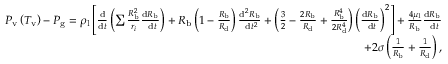Convert formula to latex. <formula><loc_0><loc_0><loc_500><loc_500>\begin{array} { r } { P _ { v } \left ( T _ { v } \right ) - P _ { g } = \rho _ { l } \left [ \frac { d } { d t } \left ( \sum \frac { R _ { b } ^ { 2 } } { r _ { i } } \frac { d R _ { b } } { d t } \right ) + R _ { b } \left ( 1 - \frac { R _ { b } } { R _ { d } } \right ) \frac { d ^ { 2 } R _ { b } } { d t ^ { 2 } } + \left ( \frac { 3 } { 2 } - \frac { 2 R _ { b } } { R _ { d } } + \frac { R _ { b } ^ { 4 } } { 2 R _ { d } ^ { 4 } } \right ) \left ( \frac { d R _ { b } } { d t } \right ) ^ { 2 } \right ] + \frac { 4 \mu _ { l } } { R _ { b } } \frac { d R _ { b } } { d t } } \\ { + 2 \sigma \left ( \frac { 1 } { R _ { b } } + \frac { 1 } { R _ { d } } \right ) , } \end{array}</formula> 